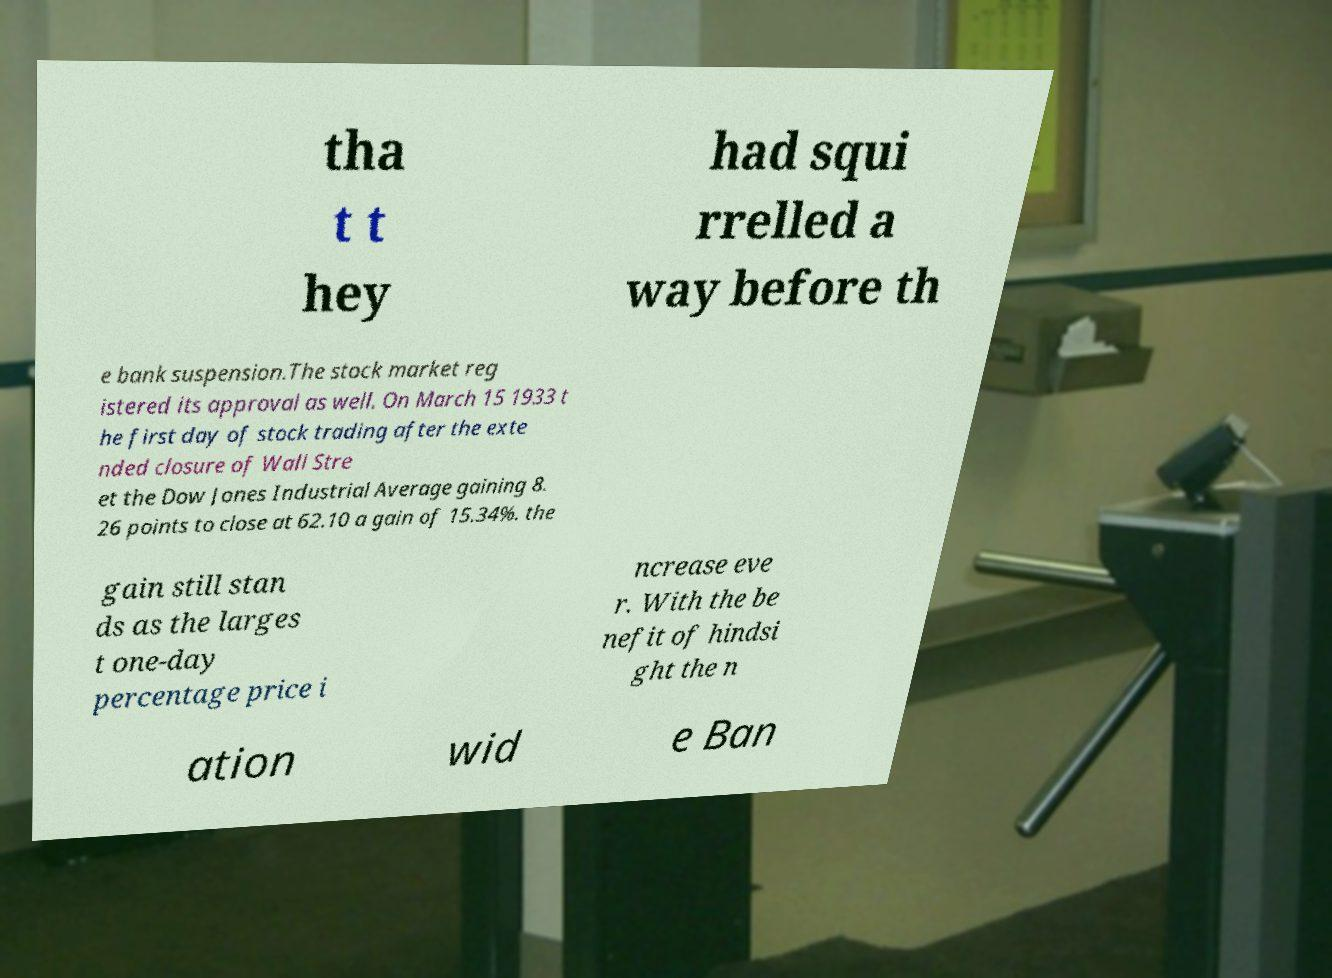For documentation purposes, I need the text within this image transcribed. Could you provide that? tha t t hey had squi rrelled a way before th e bank suspension.The stock market reg istered its approval as well. On March 15 1933 t he first day of stock trading after the exte nded closure of Wall Stre et the Dow Jones Industrial Average gaining 8. 26 points to close at 62.10 a gain of 15.34%. the gain still stan ds as the larges t one-day percentage price i ncrease eve r. With the be nefit of hindsi ght the n ation wid e Ban 